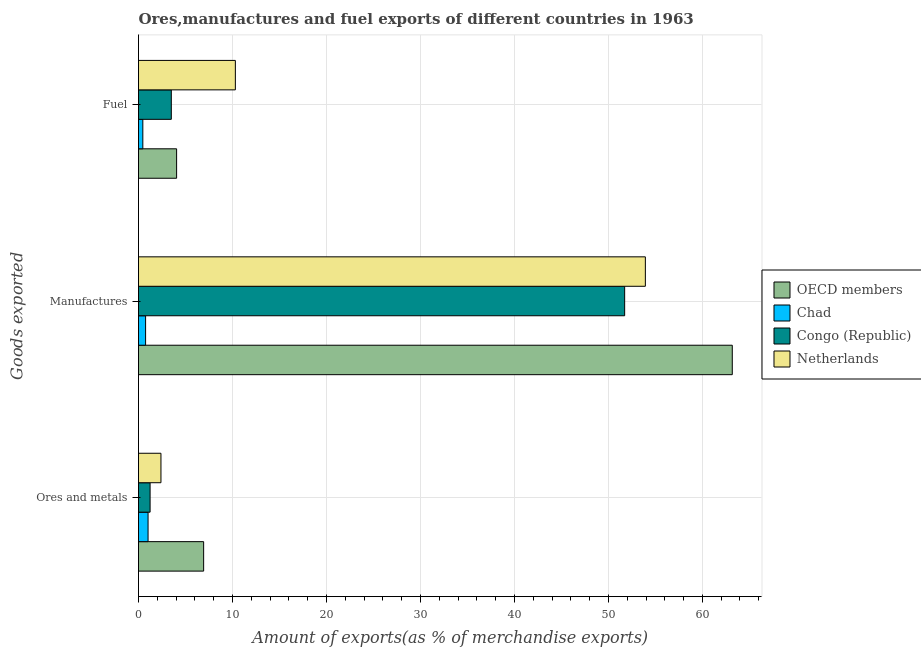How many groups of bars are there?
Offer a very short reply. 3. Are the number of bars per tick equal to the number of legend labels?
Make the answer very short. Yes. What is the label of the 1st group of bars from the top?
Provide a short and direct response. Fuel. What is the percentage of ores and metals exports in Congo (Republic)?
Offer a terse response. 1.23. Across all countries, what is the maximum percentage of manufactures exports?
Ensure brevity in your answer.  63.18. Across all countries, what is the minimum percentage of fuel exports?
Your answer should be very brief. 0.46. In which country was the percentage of manufactures exports minimum?
Make the answer very short. Chad. What is the total percentage of fuel exports in the graph?
Keep it short and to the point. 18.31. What is the difference between the percentage of ores and metals exports in OECD members and that in Congo (Republic)?
Offer a very short reply. 5.7. What is the difference between the percentage of manufactures exports in Netherlands and the percentage of fuel exports in Congo (Republic)?
Provide a succinct answer. 50.44. What is the average percentage of ores and metals exports per country?
Make the answer very short. 2.89. What is the difference between the percentage of fuel exports and percentage of ores and metals exports in Chad?
Offer a very short reply. -0.56. In how many countries, is the percentage of manufactures exports greater than 36 %?
Provide a succinct answer. 3. What is the ratio of the percentage of fuel exports in Netherlands to that in Congo (Republic)?
Provide a succinct answer. 2.95. Is the percentage of fuel exports in Netherlands less than that in Congo (Republic)?
Give a very brief answer. No. Is the difference between the percentage of fuel exports in Chad and OECD members greater than the difference between the percentage of ores and metals exports in Chad and OECD members?
Offer a very short reply. Yes. What is the difference between the highest and the second highest percentage of fuel exports?
Your answer should be very brief. 6.25. What is the difference between the highest and the lowest percentage of manufactures exports?
Your response must be concise. 62.43. In how many countries, is the percentage of ores and metals exports greater than the average percentage of ores and metals exports taken over all countries?
Offer a very short reply. 1. What does the 2nd bar from the top in Manufactures represents?
Your response must be concise. Congo (Republic). What does the 3rd bar from the bottom in Fuel represents?
Make the answer very short. Congo (Republic). Is it the case that in every country, the sum of the percentage of ores and metals exports and percentage of manufactures exports is greater than the percentage of fuel exports?
Your response must be concise. Yes. How many bars are there?
Offer a very short reply. 12. Are all the bars in the graph horizontal?
Your answer should be very brief. Yes. What is the difference between two consecutive major ticks on the X-axis?
Your answer should be very brief. 10. Does the graph contain grids?
Keep it short and to the point. Yes. Where does the legend appear in the graph?
Your response must be concise. Center right. How are the legend labels stacked?
Ensure brevity in your answer.  Vertical. What is the title of the graph?
Give a very brief answer. Ores,manufactures and fuel exports of different countries in 1963. Does "Iran" appear as one of the legend labels in the graph?
Offer a very short reply. No. What is the label or title of the X-axis?
Provide a short and direct response. Amount of exports(as % of merchandise exports). What is the label or title of the Y-axis?
Give a very brief answer. Goods exported. What is the Amount of exports(as % of merchandise exports) in OECD members in Ores and metals?
Offer a very short reply. 6.93. What is the Amount of exports(as % of merchandise exports) of Chad in Ores and metals?
Provide a short and direct response. 1.02. What is the Amount of exports(as % of merchandise exports) of Congo (Republic) in Ores and metals?
Your answer should be compact. 1.23. What is the Amount of exports(as % of merchandise exports) in Netherlands in Ores and metals?
Give a very brief answer. 2.39. What is the Amount of exports(as % of merchandise exports) in OECD members in Manufactures?
Provide a short and direct response. 63.18. What is the Amount of exports(as % of merchandise exports) in Chad in Manufactures?
Give a very brief answer. 0.75. What is the Amount of exports(as % of merchandise exports) in Congo (Republic) in Manufactures?
Provide a succinct answer. 51.73. What is the Amount of exports(as % of merchandise exports) of Netherlands in Manufactures?
Give a very brief answer. 53.93. What is the Amount of exports(as % of merchandise exports) of OECD members in Fuel?
Your response must be concise. 4.05. What is the Amount of exports(as % of merchandise exports) in Chad in Fuel?
Offer a terse response. 0.46. What is the Amount of exports(as % of merchandise exports) in Congo (Republic) in Fuel?
Your answer should be very brief. 3.49. What is the Amount of exports(as % of merchandise exports) in Netherlands in Fuel?
Provide a short and direct response. 10.31. Across all Goods exported, what is the maximum Amount of exports(as % of merchandise exports) of OECD members?
Your answer should be compact. 63.18. Across all Goods exported, what is the maximum Amount of exports(as % of merchandise exports) in Chad?
Your answer should be very brief. 1.02. Across all Goods exported, what is the maximum Amount of exports(as % of merchandise exports) of Congo (Republic)?
Make the answer very short. 51.73. Across all Goods exported, what is the maximum Amount of exports(as % of merchandise exports) in Netherlands?
Give a very brief answer. 53.93. Across all Goods exported, what is the minimum Amount of exports(as % of merchandise exports) in OECD members?
Give a very brief answer. 4.05. Across all Goods exported, what is the minimum Amount of exports(as % of merchandise exports) in Chad?
Provide a short and direct response. 0.46. Across all Goods exported, what is the minimum Amount of exports(as % of merchandise exports) of Congo (Republic)?
Your answer should be very brief. 1.23. Across all Goods exported, what is the minimum Amount of exports(as % of merchandise exports) in Netherlands?
Provide a succinct answer. 2.39. What is the total Amount of exports(as % of merchandise exports) in OECD members in the graph?
Your response must be concise. 74.17. What is the total Amount of exports(as % of merchandise exports) of Chad in the graph?
Keep it short and to the point. 2.23. What is the total Amount of exports(as % of merchandise exports) of Congo (Republic) in the graph?
Provide a short and direct response. 56.45. What is the total Amount of exports(as % of merchandise exports) of Netherlands in the graph?
Your response must be concise. 66.63. What is the difference between the Amount of exports(as % of merchandise exports) of OECD members in Ores and metals and that in Manufactures?
Your answer should be compact. -56.25. What is the difference between the Amount of exports(as % of merchandise exports) in Chad in Ores and metals and that in Manufactures?
Provide a short and direct response. 0.26. What is the difference between the Amount of exports(as % of merchandise exports) in Congo (Republic) in Ores and metals and that in Manufactures?
Provide a succinct answer. -50.5. What is the difference between the Amount of exports(as % of merchandise exports) of Netherlands in Ores and metals and that in Manufactures?
Make the answer very short. -51.54. What is the difference between the Amount of exports(as % of merchandise exports) in OECD members in Ores and metals and that in Fuel?
Your answer should be very brief. 2.88. What is the difference between the Amount of exports(as % of merchandise exports) of Chad in Ores and metals and that in Fuel?
Offer a very short reply. 0.56. What is the difference between the Amount of exports(as % of merchandise exports) of Congo (Republic) in Ores and metals and that in Fuel?
Provide a succinct answer. -2.26. What is the difference between the Amount of exports(as % of merchandise exports) of Netherlands in Ores and metals and that in Fuel?
Keep it short and to the point. -7.92. What is the difference between the Amount of exports(as % of merchandise exports) of OECD members in Manufactures and that in Fuel?
Make the answer very short. 59.13. What is the difference between the Amount of exports(as % of merchandise exports) of Chad in Manufactures and that in Fuel?
Make the answer very short. 0.3. What is the difference between the Amount of exports(as % of merchandise exports) of Congo (Republic) in Manufactures and that in Fuel?
Make the answer very short. 48.24. What is the difference between the Amount of exports(as % of merchandise exports) of Netherlands in Manufactures and that in Fuel?
Give a very brief answer. 43.63. What is the difference between the Amount of exports(as % of merchandise exports) of OECD members in Ores and metals and the Amount of exports(as % of merchandise exports) of Chad in Manufactures?
Your answer should be very brief. 6.18. What is the difference between the Amount of exports(as % of merchandise exports) in OECD members in Ores and metals and the Amount of exports(as % of merchandise exports) in Congo (Republic) in Manufactures?
Your answer should be compact. -44.8. What is the difference between the Amount of exports(as % of merchandise exports) in OECD members in Ores and metals and the Amount of exports(as % of merchandise exports) in Netherlands in Manufactures?
Provide a succinct answer. -47. What is the difference between the Amount of exports(as % of merchandise exports) in Chad in Ores and metals and the Amount of exports(as % of merchandise exports) in Congo (Republic) in Manufactures?
Provide a short and direct response. -50.71. What is the difference between the Amount of exports(as % of merchandise exports) of Chad in Ores and metals and the Amount of exports(as % of merchandise exports) of Netherlands in Manufactures?
Offer a very short reply. -52.92. What is the difference between the Amount of exports(as % of merchandise exports) in Congo (Republic) in Ores and metals and the Amount of exports(as % of merchandise exports) in Netherlands in Manufactures?
Your answer should be compact. -52.7. What is the difference between the Amount of exports(as % of merchandise exports) of OECD members in Ores and metals and the Amount of exports(as % of merchandise exports) of Chad in Fuel?
Your answer should be compact. 6.47. What is the difference between the Amount of exports(as % of merchandise exports) of OECD members in Ores and metals and the Amount of exports(as % of merchandise exports) of Congo (Republic) in Fuel?
Keep it short and to the point. 3.44. What is the difference between the Amount of exports(as % of merchandise exports) of OECD members in Ores and metals and the Amount of exports(as % of merchandise exports) of Netherlands in Fuel?
Give a very brief answer. -3.37. What is the difference between the Amount of exports(as % of merchandise exports) of Chad in Ores and metals and the Amount of exports(as % of merchandise exports) of Congo (Republic) in Fuel?
Your response must be concise. -2.47. What is the difference between the Amount of exports(as % of merchandise exports) in Chad in Ores and metals and the Amount of exports(as % of merchandise exports) in Netherlands in Fuel?
Offer a very short reply. -9.29. What is the difference between the Amount of exports(as % of merchandise exports) in Congo (Republic) in Ores and metals and the Amount of exports(as % of merchandise exports) in Netherlands in Fuel?
Make the answer very short. -9.07. What is the difference between the Amount of exports(as % of merchandise exports) in OECD members in Manufactures and the Amount of exports(as % of merchandise exports) in Chad in Fuel?
Make the answer very short. 62.72. What is the difference between the Amount of exports(as % of merchandise exports) in OECD members in Manufactures and the Amount of exports(as % of merchandise exports) in Congo (Republic) in Fuel?
Give a very brief answer. 59.69. What is the difference between the Amount of exports(as % of merchandise exports) in OECD members in Manufactures and the Amount of exports(as % of merchandise exports) in Netherlands in Fuel?
Give a very brief answer. 52.88. What is the difference between the Amount of exports(as % of merchandise exports) of Chad in Manufactures and the Amount of exports(as % of merchandise exports) of Congo (Republic) in Fuel?
Keep it short and to the point. -2.74. What is the difference between the Amount of exports(as % of merchandise exports) of Chad in Manufactures and the Amount of exports(as % of merchandise exports) of Netherlands in Fuel?
Your answer should be very brief. -9.55. What is the difference between the Amount of exports(as % of merchandise exports) in Congo (Republic) in Manufactures and the Amount of exports(as % of merchandise exports) in Netherlands in Fuel?
Make the answer very short. 41.42. What is the average Amount of exports(as % of merchandise exports) in OECD members per Goods exported?
Your answer should be compact. 24.72. What is the average Amount of exports(as % of merchandise exports) in Chad per Goods exported?
Keep it short and to the point. 0.74. What is the average Amount of exports(as % of merchandise exports) in Congo (Republic) per Goods exported?
Make the answer very short. 18.82. What is the average Amount of exports(as % of merchandise exports) in Netherlands per Goods exported?
Give a very brief answer. 22.21. What is the difference between the Amount of exports(as % of merchandise exports) in OECD members and Amount of exports(as % of merchandise exports) in Chad in Ores and metals?
Keep it short and to the point. 5.91. What is the difference between the Amount of exports(as % of merchandise exports) in OECD members and Amount of exports(as % of merchandise exports) in Congo (Republic) in Ores and metals?
Your response must be concise. 5.7. What is the difference between the Amount of exports(as % of merchandise exports) in OECD members and Amount of exports(as % of merchandise exports) in Netherlands in Ores and metals?
Keep it short and to the point. 4.54. What is the difference between the Amount of exports(as % of merchandise exports) in Chad and Amount of exports(as % of merchandise exports) in Congo (Republic) in Ores and metals?
Your answer should be very brief. -0.22. What is the difference between the Amount of exports(as % of merchandise exports) of Chad and Amount of exports(as % of merchandise exports) of Netherlands in Ores and metals?
Provide a succinct answer. -1.37. What is the difference between the Amount of exports(as % of merchandise exports) in Congo (Republic) and Amount of exports(as % of merchandise exports) in Netherlands in Ores and metals?
Offer a very short reply. -1.16. What is the difference between the Amount of exports(as % of merchandise exports) in OECD members and Amount of exports(as % of merchandise exports) in Chad in Manufactures?
Keep it short and to the point. 62.43. What is the difference between the Amount of exports(as % of merchandise exports) of OECD members and Amount of exports(as % of merchandise exports) of Congo (Republic) in Manufactures?
Your answer should be compact. 11.45. What is the difference between the Amount of exports(as % of merchandise exports) of OECD members and Amount of exports(as % of merchandise exports) of Netherlands in Manufactures?
Make the answer very short. 9.25. What is the difference between the Amount of exports(as % of merchandise exports) in Chad and Amount of exports(as % of merchandise exports) in Congo (Republic) in Manufactures?
Your answer should be very brief. -50.97. What is the difference between the Amount of exports(as % of merchandise exports) in Chad and Amount of exports(as % of merchandise exports) in Netherlands in Manufactures?
Provide a short and direct response. -53.18. What is the difference between the Amount of exports(as % of merchandise exports) of Congo (Republic) and Amount of exports(as % of merchandise exports) of Netherlands in Manufactures?
Ensure brevity in your answer.  -2.2. What is the difference between the Amount of exports(as % of merchandise exports) of OECD members and Amount of exports(as % of merchandise exports) of Chad in Fuel?
Make the answer very short. 3.59. What is the difference between the Amount of exports(as % of merchandise exports) of OECD members and Amount of exports(as % of merchandise exports) of Congo (Republic) in Fuel?
Provide a short and direct response. 0.56. What is the difference between the Amount of exports(as % of merchandise exports) of OECD members and Amount of exports(as % of merchandise exports) of Netherlands in Fuel?
Ensure brevity in your answer.  -6.25. What is the difference between the Amount of exports(as % of merchandise exports) of Chad and Amount of exports(as % of merchandise exports) of Congo (Republic) in Fuel?
Offer a very short reply. -3.03. What is the difference between the Amount of exports(as % of merchandise exports) in Chad and Amount of exports(as % of merchandise exports) in Netherlands in Fuel?
Offer a very short reply. -9.85. What is the difference between the Amount of exports(as % of merchandise exports) of Congo (Republic) and Amount of exports(as % of merchandise exports) of Netherlands in Fuel?
Provide a succinct answer. -6.81. What is the ratio of the Amount of exports(as % of merchandise exports) of OECD members in Ores and metals to that in Manufactures?
Provide a succinct answer. 0.11. What is the ratio of the Amount of exports(as % of merchandise exports) in Chad in Ores and metals to that in Manufactures?
Your response must be concise. 1.35. What is the ratio of the Amount of exports(as % of merchandise exports) in Congo (Republic) in Ores and metals to that in Manufactures?
Your response must be concise. 0.02. What is the ratio of the Amount of exports(as % of merchandise exports) in Netherlands in Ores and metals to that in Manufactures?
Make the answer very short. 0.04. What is the ratio of the Amount of exports(as % of merchandise exports) of OECD members in Ores and metals to that in Fuel?
Your answer should be compact. 1.71. What is the ratio of the Amount of exports(as % of merchandise exports) in Chad in Ores and metals to that in Fuel?
Offer a terse response. 2.21. What is the ratio of the Amount of exports(as % of merchandise exports) of Congo (Republic) in Ores and metals to that in Fuel?
Your answer should be compact. 0.35. What is the ratio of the Amount of exports(as % of merchandise exports) in Netherlands in Ores and metals to that in Fuel?
Provide a short and direct response. 0.23. What is the ratio of the Amount of exports(as % of merchandise exports) in OECD members in Manufactures to that in Fuel?
Provide a short and direct response. 15.59. What is the ratio of the Amount of exports(as % of merchandise exports) in Chad in Manufactures to that in Fuel?
Your response must be concise. 1.64. What is the ratio of the Amount of exports(as % of merchandise exports) of Congo (Republic) in Manufactures to that in Fuel?
Ensure brevity in your answer.  14.82. What is the ratio of the Amount of exports(as % of merchandise exports) of Netherlands in Manufactures to that in Fuel?
Your response must be concise. 5.23. What is the difference between the highest and the second highest Amount of exports(as % of merchandise exports) in OECD members?
Provide a short and direct response. 56.25. What is the difference between the highest and the second highest Amount of exports(as % of merchandise exports) of Chad?
Give a very brief answer. 0.26. What is the difference between the highest and the second highest Amount of exports(as % of merchandise exports) in Congo (Republic)?
Your answer should be very brief. 48.24. What is the difference between the highest and the second highest Amount of exports(as % of merchandise exports) of Netherlands?
Your answer should be very brief. 43.63. What is the difference between the highest and the lowest Amount of exports(as % of merchandise exports) of OECD members?
Offer a very short reply. 59.13. What is the difference between the highest and the lowest Amount of exports(as % of merchandise exports) in Chad?
Your response must be concise. 0.56. What is the difference between the highest and the lowest Amount of exports(as % of merchandise exports) in Congo (Republic)?
Offer a very short reply. 50.5. What is the difference between the highest and the lowest Amount of exports(as % of merchandise exports) in Netherlands?
Provide a short and direct response. 51.54. 